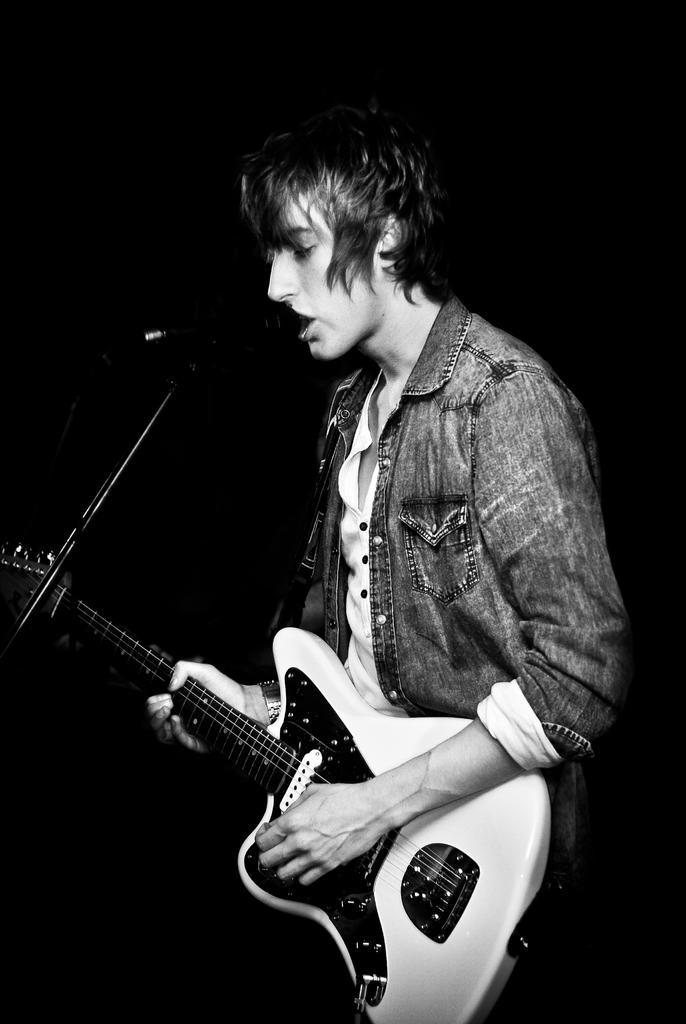Can you describe this image briefly? Here is a man who is singing a song, he is wearing a jacket and holding a guitar in his hand ,in the background is black. 